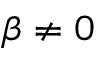Convert formula to latex. <formula><loc_0><loc_0><loc_500><loc_500>\beta \ne 0</formula> 